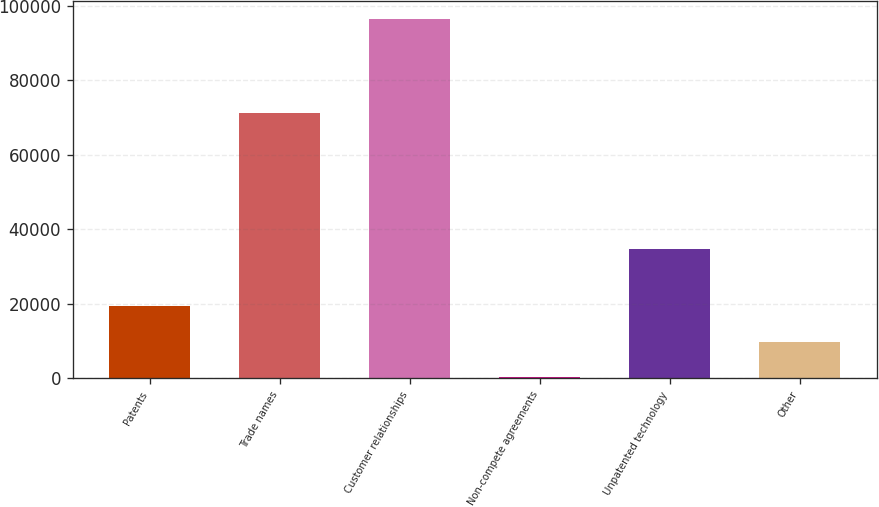Convert chart. <chart><loc_0><loc_0><loc_500><loc_500><bar_chart><fcel>Patents<fcel>Trade names<fcel>Customer relationships<fcel>Non-compete agreements<fcel>Unpatented technology<fcel>Other<nl><fcel>19421.8<fcel>71237<fcel>96293<fcel>204<fcel>34595<fcel>9812.9<nl></chart> 